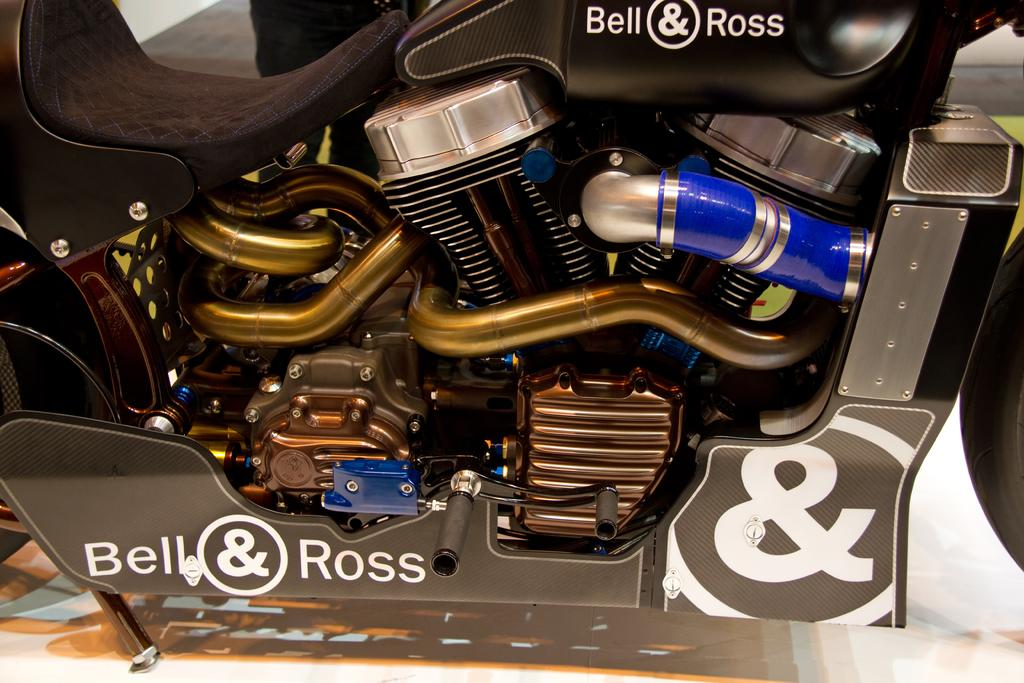What type of machinery is featured in the image? The image contains the engine of a motorcycle. Can you describe the engine in more detail? Unfortunately, the image does not provide enough detail to describe the engine further. What is the primary function of the engine in the image? The engine is responsible for powering the motorcycle. What type of stove is visible in the image? There is no stove present in the image; it features the engine of a motorcycle. Can you describe the blood type of the motorcycle's partner in the image? There is no partner or blood type mentioned in the image, as it only features the engine of a motorcycle. 